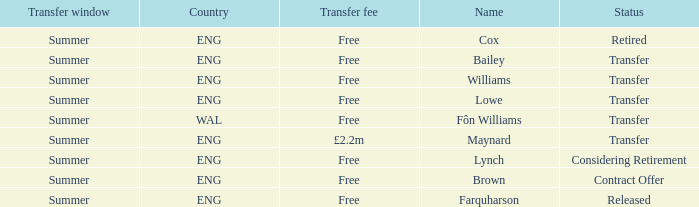What is the status of the Eng Country from the Maynard name? Transfer. 